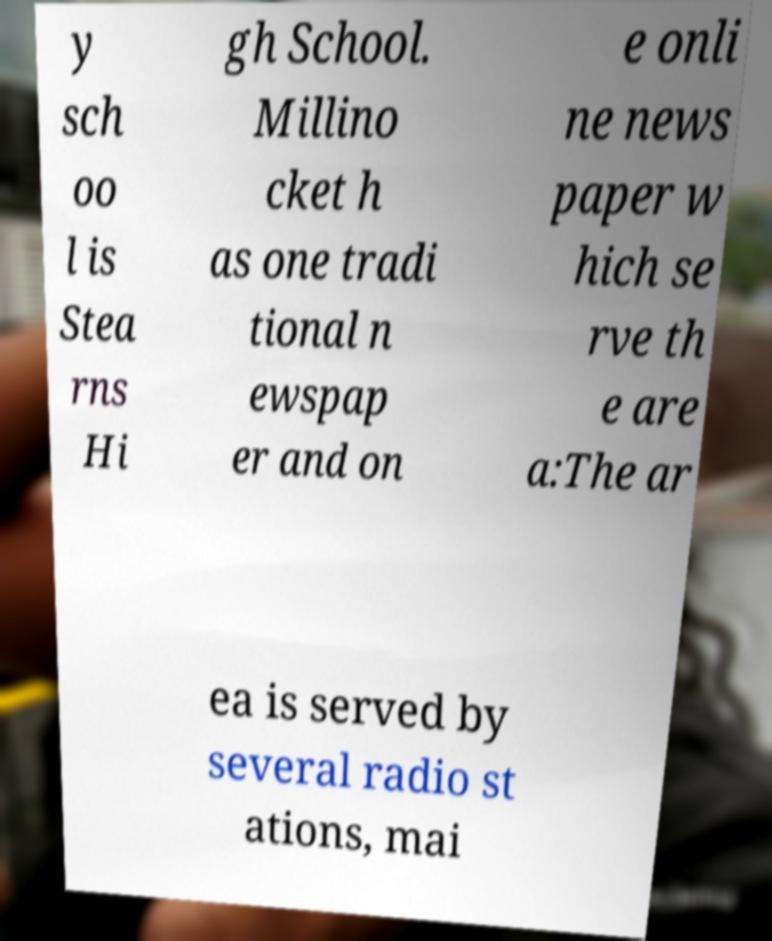Could you extract and type out the text from this image? y sch oo l is Stea rns Hi gh School. Millino cket h as one tradi tional n ewspap er and on e onli ne news paper w hich se rve th e are a:The ar ea is served by several radio st ations, mai 